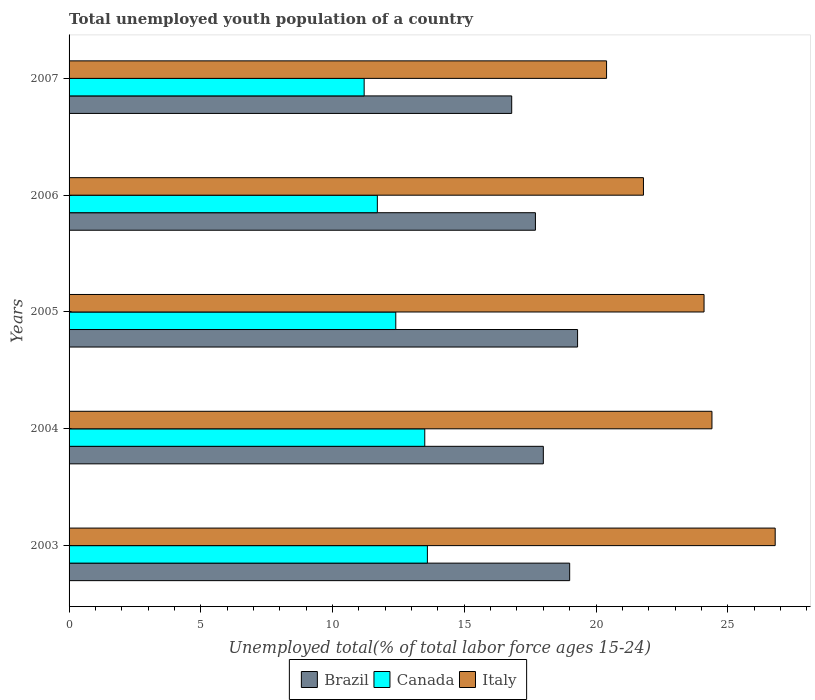How many different coloured bars are there?
Offer a terse response. 3. Are the number of bars per tick equal to the number of legend labels?
Your response must be concise. Yes. What is the label of the 1st group of bars from the top?
Ensure brevity in your answer.  2007. In how many cases, is the number of bars for a given year not equal to the number of legend labels?
Your answer should be very brief. 0. What is the percentage of total unemployed youth population of a country in Italy in 2003?
Ensure brevity in your answer.  26.8. Across all years, what is the maximum percentage of total unemployed youth population of a country in Brazil?
Offer a very short reply. 19.3. Across all years, what is the minimum percentage of total unemployed youth population of a country in Italy?
Make the answer very short. 20.4. In which year was the percentage of total unemployed youth population of a country in Brazil minimum?
Offer a terse response. 2007. What is the total percentage of total unemployed youth population of a country in Italy in the graph?
Offer a terse response. 117.5. What is the difference between the percentage of total unemployed youth population of a country in Brazil in 2006 and that in 2007?
Your response must be concise. 0.9. What is the difference between the percentage of total unemployed youth population of a country in Italy in 2004 and the percentage of total unemployed youth population of a country in Brazil in 2003?
Your answer should be very brief. 5.4. What is the average percentage of total unemployed youth population of a country in Canada per year?
Provide a short and direct response. 12.48. In the year 2007, what is the difference between the percentage of total unemployed youth population of a country in Italy and percentage of total unemployed youth population of a country in Canada?
Keep it short and to the point. 9.2. What is the ratio of the percentage of total unemployed youth population of a country in Italy in 2005 to that in 2007?
Provide a short and direct response. 1.18. Is the percentage of total unemployed youth population of a country in Canada in 2003 less than that in 2004?
Keep it short and to the point. No. What is the difference between the highest and the second highest percentage of total unemployed youth population of a country in Canada?
Make the answer very short. 0.1. What does the 1st bar from the top in 2005 represents?
Ensure brevity in your answer.  Italy. What does the 1st bar from the bottom in 2006 represents?
Your response must be concise. Brazil. Is it the case that in every year, the sum of the percentage of total unemployed youth population of a country in Italy and percentage of total unemployed youth population of a country in Canada is greater than the percentage of total unemployed youth population of a country in Brazil?
Make the answer very short. Yes. How many bars are there?
Keep it short and to the point. 15. How many years are there in the graph?
Provide a succinct answer. 5. Are the values on the major ticks of X-axis written in scientific E-notation?
Ensure brevity in your answer.  No. How many legend labels are there?
Offer a very short reply. 3. What is the title of the graph?
Your answer should be compact. Total unemployed youth population of a country. Does "Malaysia" appear as one of the legend labels in the graph?
Your response must be concise. No. What is the label or title of the X-axis?
Your response must be concise. Unemployed total(% of total labor force ages 15-24). What is the Unemployed total(% of total labor force ages 15-24) in Brazil in 2003?
Ensure brevity in your answer.  19. What is the Unemployed total(% of total labor force ages 15-24) of Canada in 2003?
Offer a terse response. 13.6. What is the Unemployed total(% of total labor force ages 15-24) in Italy in 2003?
Make the answer very short. 26.8. What is the Unemployed total(% of total labor force ages 15-24) in Brazil in 2004?
Your answer should be compact. 18. What is the Unemployed total(% of total labor force ages 15-24) in Italy in 2004?
Your answer should be very brief. 24.4. What is the Unemployed total(% of total labor force ages 15-24) of Brazil in 2005?
Ensure brevity in your answer.  19.3. What is the Unemployed total(% of total labor force ages 15-24) in Canada in 2005?
Provide a succinct answer. 12.4. What is the Unemployed total(% of total labor force ages 15-24) of Italy in 2005?
Give a very brief answer. 24.1. What is the Unemployed total(% of total labor force ages 15-24) of Brazil in 2006?
Ensure brevity in your answer.  17.7. What is the Unemployed total(% of total labor force ages 15-24) of Canada in 2006?
Give a very brief answer. 11.7. What is the Unemployed total(% of total labor force ages 15-24) in Italy in 2006?
Give a very brief answer. 21.8. What is the Unemployed total(% of total labor force ages 15-24) in Brazil in 2007?
Make the answer very short. 16.8. What is the Unemployed total(% of total labor force ages 15-24) of Canada in 2007?
Provide a succinct answer. 11.2. What is the Unemployed total(% of total labor force ages 15-24) in Italy in 2007?
Ensure brevity in your answer.  20.4. Across all years, what is the maximum Unemployed total(% of total labor force ages 15-24) of Brazil?
Offer a very short reply. 19.3. Across all years, what is the maximum Unemployed total(% of total labor force ages 15-24) in Canada?
Offer a very short reply. 13.6. Across all years, what is the maximum Unemployed total(% of total labor force ages 15-24) in Italy?
Ensure brevity in your answer.  26.8. Across all years, what is the minimum Unemployed total(% of total labor force ages 15-24) in Brazil?
Your answer should be very brief. 16.8. Across all years, what is the minimum Unemployed total(% of total labor force ages 15-24) in Canada?
Make the answer very short. 11.2. Across all years, what is the minimum Unemployed total(% of total labor force ages 15-24) of Italy?
Your answer should be compact. 20.4. What is the total Unemployed total(% of total labor force ages 15-24) of Brazil in the graph?
Ensure brevity in your answer.  90.8. What is the total Unemployed total(% of total labor force ages 15-24) in Canada in the graph?
Give a very brief answer. 62.4. What is the total Unemployed total(% of total labor force ages 15-24) in Italy in the graph?
Your answer should be very brief. 117.5. What is the difference between the Unemployed total(% of total labor force ages 15-24) in Italy in 2003 and that in 2004?
Ensure brevity in your answer.  2.4. What is the difference between the Unemployed total(% of total labor force ages 15-24) of Italy in 2003 and that in 2005?
Ensure brevity in your answer.  2.7. What is the difference between the Unemployed total(% of total labor force ages 15-24) of Brazil in 2003 and that in 2006?
Your answer should be compact. 1.3. What is the difference between the Unemployed total(% of total labor force ages 15-24) in Canada in 2003 and that in 2006?
Offer a very short reply. 1.9. What is the difference between the Unemployed total(% of total labor force ages 15-24) of Italy in 2003 and that in 2006?
Your answer should be very brief. 5. What is the difference between the Unemployed total(% of total labor force ages 15-24) in Canada in 2003 and that in 2007?
Keep it short and to the point. 2.4. What is the difference between the Unemployed total(% of total labor force ages 15-24) in Canada in 2004 and that in 2005?
Your response must be concise. 1.1. What is the difference between the Unemployed total(% of total labor force ages 15-24) in Italy in 2004 and that in 2006?
Your answer should be compact. 2.6. What is the difference between the Unemployed total(% of total labor force ages 15-24) in Canada in 2004 and that in 2007?
Provide a short and direct response. 2.3. What is the difference between the Unemployed total(% of total labor force ages 15-24) in Canada in 2005 and that in 2006?
Ensure brevity in your answer.  0.7. What is the difference between the Unemployed total(% of total labor force ages 15-24) in Italy in 2005 and that in 2006?
Your answer should be compact. 2.3. What is the difference between the Unemployed total(% of total labor force ages 15-24) of Italy in 2005 and that in 2007?
Ensure brevity in your answer.  3.7. What is the difference between the Unemployed total(% of total labor force ages 15-24) in Canada in 2006 and that in 2007?
Give a very brief answer. 0.5. What is the difference between the Unemployed total(% of total labor force ages 15-24) in Italy in 2006 and that in 2007?
Your answer should be very brief. 1.4. What is the difference between the Unemployed total(% of total labor force ages 15-24) in Brazil in 2003 and the Unemployed total(% of total labor force ages 15-24) in Canada in 2005?
Your answer should be very brief. 6.6. What is the difference between the Unemployed total(% of total labor force ages 15-24) in Brazil in 2003 and the Unemployed total(% of total labor force ages 15-24) in Italy in 2005?
Provide a succinct answer. -5.1. What is the difference between the Unemployed total(% of total labor force ages 15-24) of Canada in 2003 and the Unemployed total(% of total labor force ages 15-24) of Italy in 2006?
Offer a terse response. -8.2. What is the difference between the Unemployed total(% of total labor force ages 15-24) in Brazil in 2004 and the Unemployed total(% of total labor force ages 15-24) in Canada in 2005?
Your answer should be very brief. 5.6. What is the difference between the Unemployed total(% of total labor force ages 15-24) of Brazil in 2004 and the Unemployed total(% of total labor force ages 15-24) of Italy in 2005?
Your answer should be compact. -6.1. What is the difference between the Unemployed total(% of total labor force ages 15-24) of Canada in 2004 and the Unemployed total(% of total labor force ages 15-24) of Italy in 2005?
Offer a very short reply. -10.6. What is the difference between the Unemployed total(% of total labor force ages 15-24) of Brazil in 2005 and the Unemployed total(% of total labor force ages 15-24) of Italy in 2006?
Offer a terse response. -2.5. What is the difference between the Unemployed total(% of total labor force ages 15-24) in Canada in 2005 and the Unemployed total(% of total labor force ages 15-24) in Italy in 2006?
Provide a short and direct response. -9.4. What is the difference between the Unemployed total(% of total labor force ages 15-24) in Brazil in 2005 and the Unemployed total(% of total labor force ages 15-24) in Canada in 2007?
Keep it short and to the point. 8.1. What is the difference between the Unemployed total(% of total labor force ages 15-24) in Brazil in 2006 and the Unemployed total(% of total labor force ages 15-24) in Italy in 2007?
Keep it short and to the point. -2.7. What is the difference between the Unemployed total(% of total labor force ages 15-24) of Canada in 2006 and the Unemployed total(% of total labor force ages 15-24) of Italy in 2007?
Keep it short and to the point. -8.7. What is the average Unemployed total(% of total labor force ages 15-24) in Brazil per year?
Provide a short and direct response. 18.16. What is the average Unemployed total(% of total labor force ages 15-24) of Canada per year?
Offer a terse response. 12.48. In the year 2003, what is the difference between the Unemployed total(% of total labor force ages 15-24) in Brazil and Unemployed total(% of total labor force ages 15-24) in Italy?
Offer a terse response. -7.8. In the year 2003, what is the difference between the Unemployed total(% of total labor force ages 15-24) in Canada and Unemployed total(% of total labor force ages 15-24) in Italy?
Provide a short and direct response. -13.2. In the year 2004, what is the difference between the Unemployed total(% of total labor force ages 15-24) of Brazil and Unemployed total(% of total labor force ages 15-24) of Canada?
Offer a terse response. 4.5. In the year 2004, what is the difference between the Unemployed total(% of total labor force ages 15-24) in Brazil and Unemployed total(% of total labor force ages 15-24) in Italy?
Provide a short and direct response. -6.4. In the year 2004, what is the difference between the Unemployed total(% of total labor force ages 15-24) of Canada and Unemployed total(% of total labor force ages 15-24) of Italy?
Your response must be concise. -10.9. In the year 2005, what is the difference between the Unemployed total(% of total labor force ages 15-24) in Brazil and Unemployed total(% of total labor force ages 15-24) in Italy?
Offer a terse response. -4.8. In the year 2006, what is the difference between the Unemployed total(% of total labor force ages 15-24) of Canada and Unemployed total(% of total labor force ages 15-24) of Italy?
Ensure brevity in your answer.  -10.1. What is the ratio of the Unemployed total(% of total labor force ages 15-24) of Brazil in 2003 to that in 2004?
Offer a terse response. 1.06. What is the ratio of the Unemployed total(% of total labor force ages 15-24) of Canada in 2003 to that in 2004?
Give a very brief answer. 1.01. What is the ratio of the Unemployed total(% of total labor force ages 15-24) of Italy in 2003 to that in 2004?
Make the answer very short. 1.1. What is the ratio of the Unemployed total(% of total labor force ages 15-24) of Brazil in 2003 to that in 2005?
Offer a very short reply. 0.98. What is the ratio of the Unemployed total(% of total labor force ages 15-24) of Canada in 2003 to that in 2005?
Make the answer very short. 1.1. What is the ratio of the Unemployed total(% of total labor force ages 15-24) of Italy in 2003 to that in 2005?
Your answer should be compact. 1.11. What is the ratio of the Unemployed total(% of total labor force ages 15-24) in Brazil in 2003 to that in 2006?
Provide a short and direct response. 1.07. What is the ratio of the Unemployed total(% of total labor force ages 15-24) of Canada in 2003 to that in 2006?
Provide a short and direct response. 1.16. What is the ratio of the Unemployed total(% of total labor force ages 15-24) in Italy in 2003 to that in 2006?
Your answer should be compact. 1.23. What is the ratio of the Unemployed total(% of total labor force ages 15-24) of Brazil in 2003 to that in 2007?
Provide a short and direct response. 1.13. What is the ratio of the Unemployed total(% of total labor force ages 15-24) of Canada in 2003 to that in 2007?
Give a very brief answer. 1.21. What is the ratio of the Unemployed total(% of total labor force ages 15-24) in Italy in 2003 to that in 2007?
Your response must be concise. 1.31. What is the ratio of the Unemployed total(% of total labor force ages 15-24) of Brazil in 2004 to that in 2005?
Your response must be concise. 0.93. What is the ratio of the Unemployed total(% of total labor force ages 15-24) in Canada in 2004 to that in 2005?
Your response must be concise. 1.09. What is the ratio of the Unemployed total(% of total labor force ages 15-24) in Italy in 2004 to that in 2005?
Provide a succinct answer. 1.01. What is the ratio of the Unemployed total(% of total labor force ages 15-24) of Brazil in 2004 to that in 2006?
Offer a very short reply. 1.02. What is the ratio of the Unemployed total(% of total labor force ages 15-24) of Canada in 2004 to that in 2006?
Give a very brief answer. 1.15. What is the ratio of the Unemployed total(% of total labor force ages 15-24) in Italy in 2004 to that in 2006?
Ensure brevity in your answer.  1.12. What is the ratio of the Unemployed total(% of total labor force ages 15-24) in Brazil in 2004 to that in 2007?
Ensure brevity in your answer.  1.07. What is the ratio of the Unemployed total(% of total labor force ages 15-24) of Canada in 2004 to that in 2007?
Provide a succinct answer. 1.21. What is the ratio of the Unemployed total(% of total labor force ages 15-24) of Italy in 2004 to that in 2007?
Offer a very short reply. 1.2. What is the ratio of the Unemployed total(% of total labor force ages 15-24) of Brazil in 2005 to that in 2006?
Give a very brief answer. 1.09. What is the ratio of the Unemployed total(% of total labor force ages 15-24) of Canada in 2005 to that in 2006?
Offer a terse response. 1.06. What is the ratio of the Unemployed total(% of total labor force ages 15-24) of Italy in 2005 to that in 2006?
Your response must be concise. 1.11. What is the ratio of the Unemployed total(% of total labor force ages 15-24) of Brazil in 2005 to that in 2007?
Give a very brief answer. 1.15. What is the ratio of the Unemployed total(% of total labor force ages 15-24) in Canada in 2005 to that in 2007?
Keep it short and to the point. 1.11. What is the ratio of the Unemployed total(% of total labor force ages 15-24) in Italy in 2005 to that in 2007?
Give a very brief answer. 1.18. What is the ratio of the Unemployed total(% of total labor force ages 15-24) of Brazil in 2006 to that in 2007?
Your answer should be compact. 1.05. What is the ratio of the Unemployed total(% of total labor force ages 15-24) of Canada in 2006 to that in 2007?
Give a very brief answer. 1.04. What is the ratio of the Unemployed total(% of total labor force ages 15-24) of Italy in 2006 to that in 2007?
Provide a succinct answer. 1.07. What is the difference between the highest and the second highest Unemployed total(% of total labor force ages 15-24) in Canada?
Offer a terse response. 0.1. What is the difference between the highest and the lowest Unemployed total(% of total labor force ages 15-24) of Brazil?
Your response must be concise. 2.5. What is the difference between the highest and the lowest Unemployed total(% of total labor force ages 15-24) in Canada?
Give a very brief answer. 2.4. What is the difference between the highest and the lowest Unemployed total(% of total labor force ages 15-24) in Italy?
Ensure brevity in your answer.  6.4. 